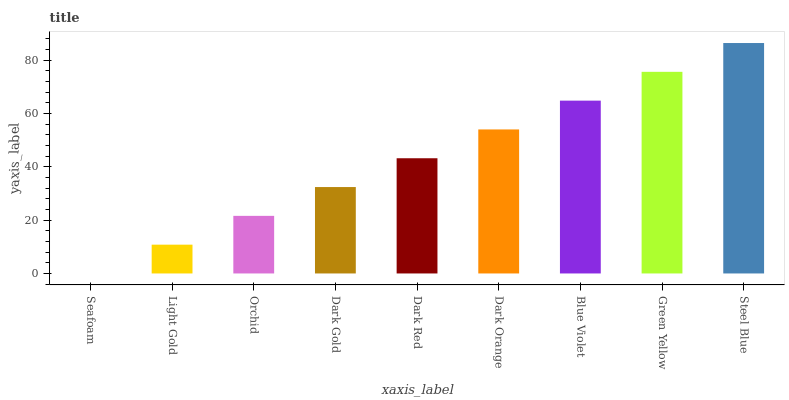Is Seafoam the minimum?
Answer yes or no. Yes. Is Steel Blue the maximum?
Answer yes or no. Yes. Is Light Gold the minimum?
Answer yes or no. No. Is Light Gold the maximum?
Answer yes or no. No. Is Light Gold greater than Seafoam?
Answer yes or no. Yes. Is Seafoam less than Light Gold?
Answer yes or no. Yes. Is Seafoam greater than Light Gold?
Answer yes or no. No. Is Light Gold less than Seafoam?
Answer yes or no. No. Is Dark Red the high median?
Answer yes or no. Yes. Is Dark Red the low median?
Answer yes or no. Yes. Is Seafoam the high median?
Answer yes or no. No. Is Light Gold the low median?
Answer yes or no. No. 